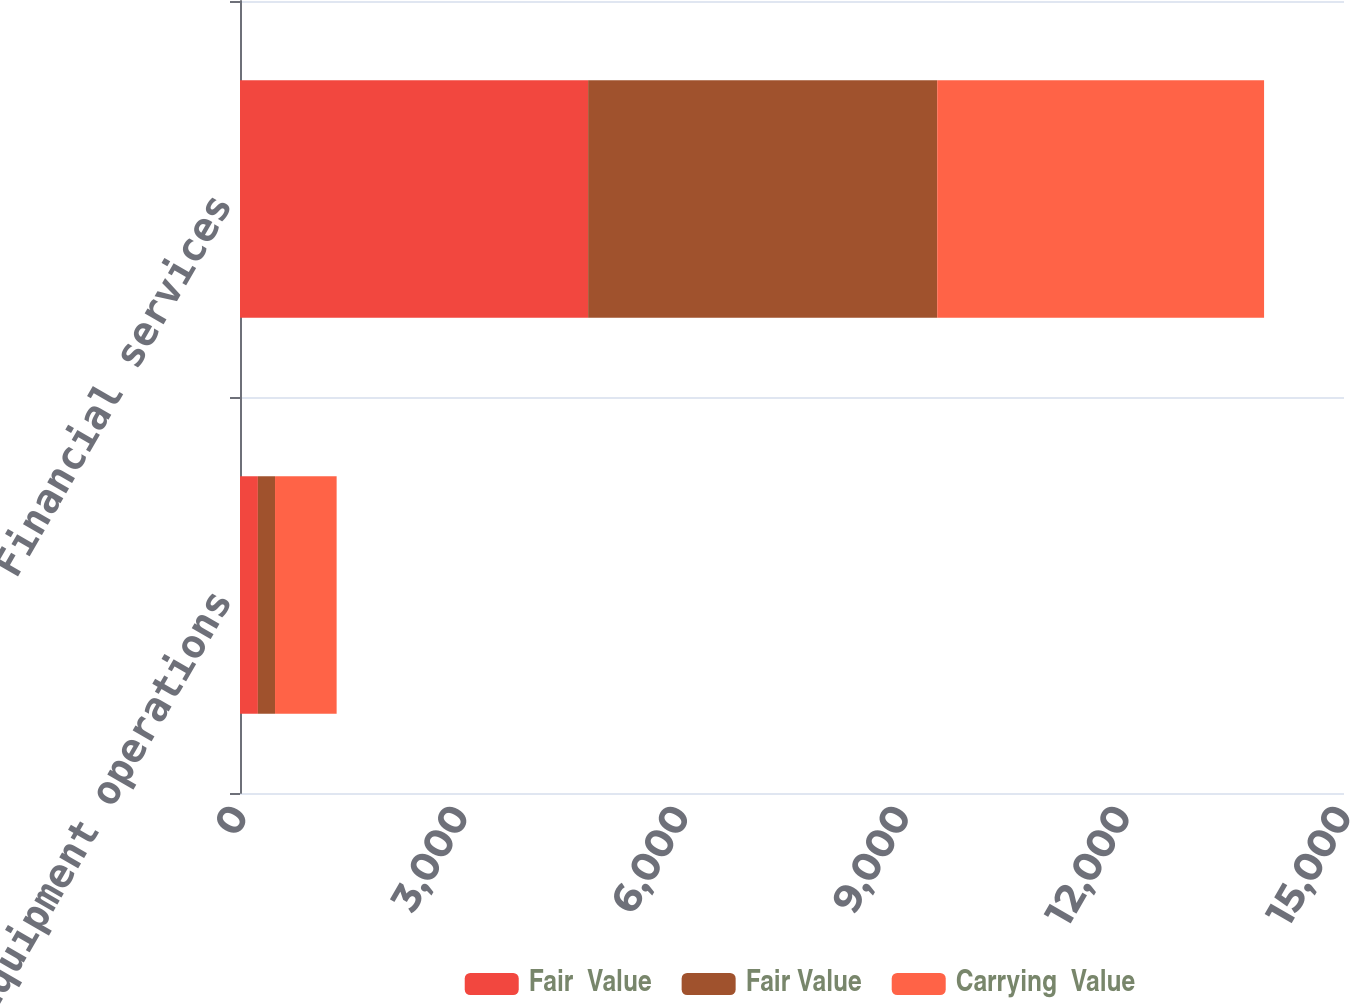Convert chart. <chart><loc_0><loc_0><loc_500><loc_500><stacked_bar_chart><ecel><fcel>Equipment operations<fcel>Financial services<nl><fcel>Fair  Value<fcel>243<fcel>4730<nl><fcel>Fair Value<fcel>233<fcel>4743<nl><fcel>Carrying  Value<fcel>837<fcel>4441<nl></chart> 